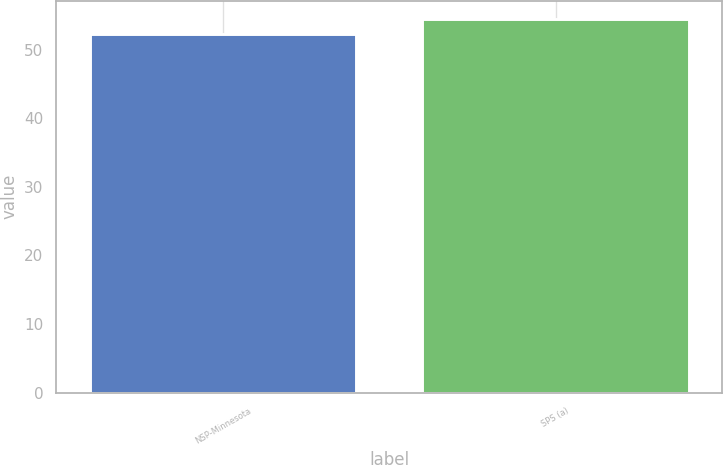Convert chart. <chart><loc_0><loc_0><loc_500><loc_500><bar_chart><fcel>NSP-Minnesota<fcel>SPS (a)<nl><fcel>52.3<fcel>54.4<nl></chart> 